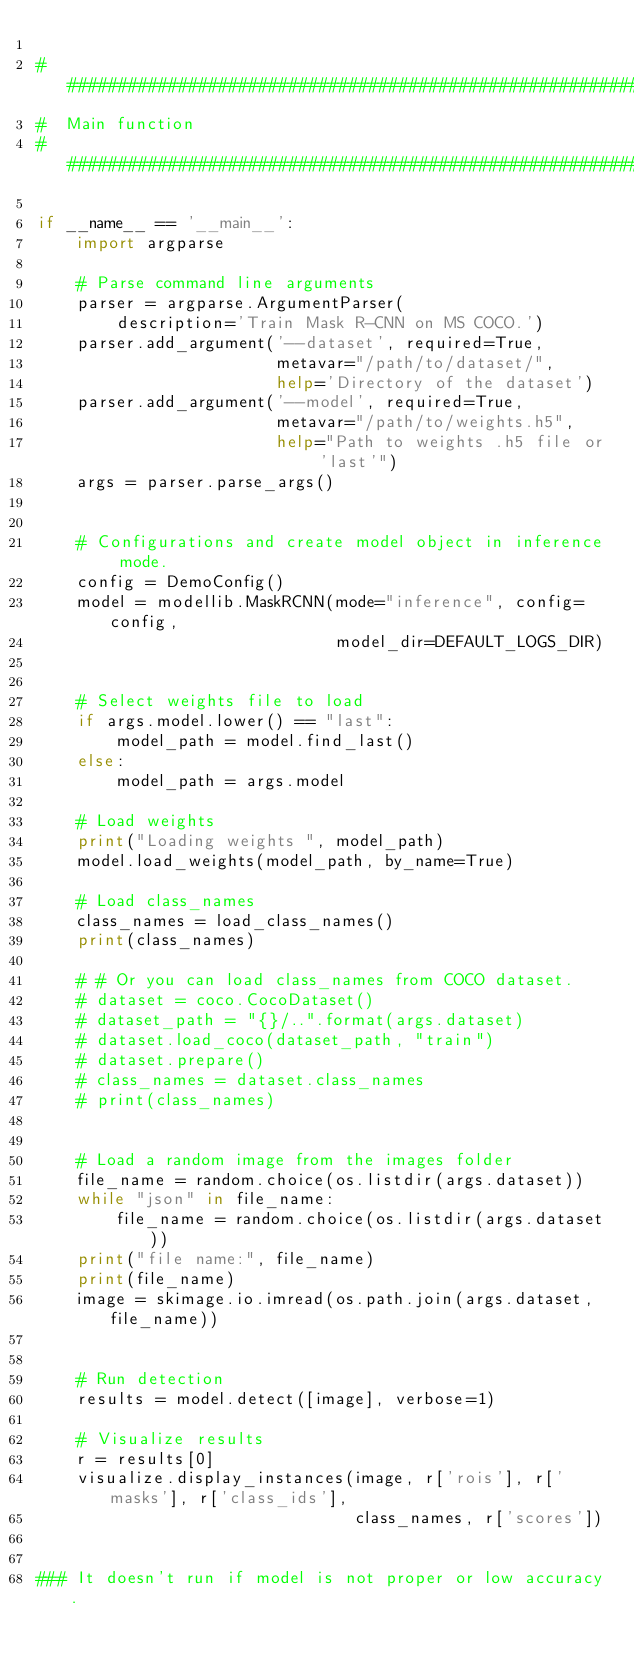Convert code to text. <code><loc_0><loc_0><loc_500><loc_500><_Python_>
############################################################
#  Main function
############################################################

if __name__ == '__main__':
    import argparse

    # Parse command line arguments
    parser = argparse.ArgumentParser(
        description='Train Mask R-CNN on MS COCO.')
    parser.add_argument('--dataset', required=True,
                        metavar="/path/to/dataset/",
                        help='Directory of the dataset')
    parser.add_argument('--model', required=True,
                        metavar="/path/to/weights.h5",
                        help="Path to weights .h5 file or 'last'")
    args = parser.parse_args()


    # Configurations and create model object in inference mode.
    config = DemoConfig()
    model = modellib.MaskRCNN(mode="inference", config=config,
                              model_dir=DEFAULT_LOGS_DIR)


    # Select weights file to load
    if args.model.lower() == "last":
        model_path = model.find_last()
    else:
        model_path = args.model

    # Load weights
    print("Loading weights ", model_path)
    model.load_weights(model_path, by_name=True)

    # Load class_names
    class_names = load_class_names()
    print(class_names)

    # # Or you can load class_names from COCO dataset.
    # dataset = coco.CocoDataset()
    # dataset_path = "{}/..".format(args.dataset)
    # dataset.load_coco(dataset_path, "train")
    # dataset.prepare()
    # class_names = dataset.class_names
    # print(class_names)


    # Load a random image from the images folder
    file_name = random.choice(os.listdir(args.dataset))
    while "json" in file_name:
        file_name = random.choice(os.listdir(args.dataset))
    print("file name:", file_name)
    print(file_name)
    image = skimage.io.imread(os.path.join(args.dataset, file_name))


    # Run detection
    results = model.detect([image], verbose=1)

    # Visualize results
    r = results[0]
    visualize.display_instances(image, r['rois'], r['masks'], r['class_ids'],
                                class_names, r['scores'])


### It doesn't run if model is not proper or low accuracy.</code> 